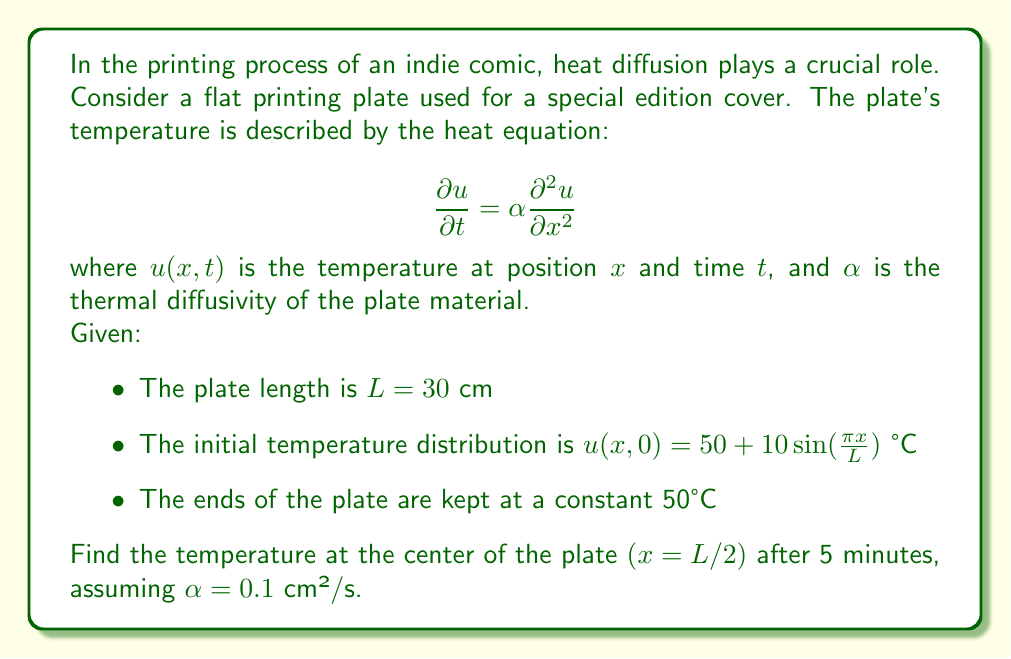What is the answer to this math problem? To solve this problem, we need to use the separation of variables method for the heat equation with the given initial and boundary conditions.

1) The general solution for the heat equation with these boundary conditions is:

   $$u(x,t) = 50 + \sum_{n=1}^{\infty} B_n \sin(\frac{n\pi x}{L}) e^{-\alpha(\frac{n\pi}{L})^2 t}$$

2) The initial condition gives us:

   $$50 + 10\sin(\frac{\pi x}{L}) = 50 + \sum_{n=1}^{\infty} B_n \sin(\frac{n\pi x}{L})$$

3) Comparing coefficients, we see that $B_1 = 10$ and $B_n = 0$ for $n > 1$.

4) Therefore, our solution simplifies to:

   $$u(x,t) = 50 + 10\sin(\frac{\pi x}{L}) e^{-\alpha(\frac{\pi}{L})^2 t}$$

5) At the center of the plate, $x = L/2 = 15$ cm. After 5 minutes, $t = 300$ s.

6) Substituting these values:

   $$u(15, 300) = 50 + 10\sin(\frac{\pi 15}{30}) e^{-0.1(\frac{\pi}{30})^2 300}$$

7) Simplify:
   
   $$u(15, 300) = 50 + 10\sin(\frac{\pi}{2}) e^{-0.1(\frac{\pi}{30})^2 300}$$
   
   $$= 50 + 10 e^{-0.1(\frac{\pi}{30})^2 300}$$

8) Calculate the exponent:
   
   $$-0.1(\frac{\pi}{30})^2 300 \approx -0.3290$$

9) Therefore:

   $$u(15, 300) = 50 + 10 e^{-0.3290} \approx 50 + 7.1975 = 57.1975$$
Answer: The temperature at the center of the plate after 5 minutes is approximately 57.20°C. 